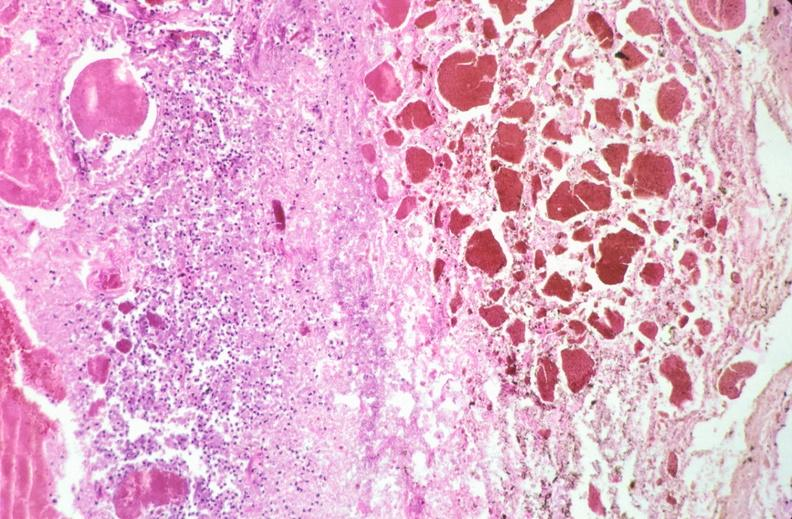s this image shows of smooth muscle cell with lipid in sarcoplasm and lipid present?
Answer the question using a single word or phrase. No 